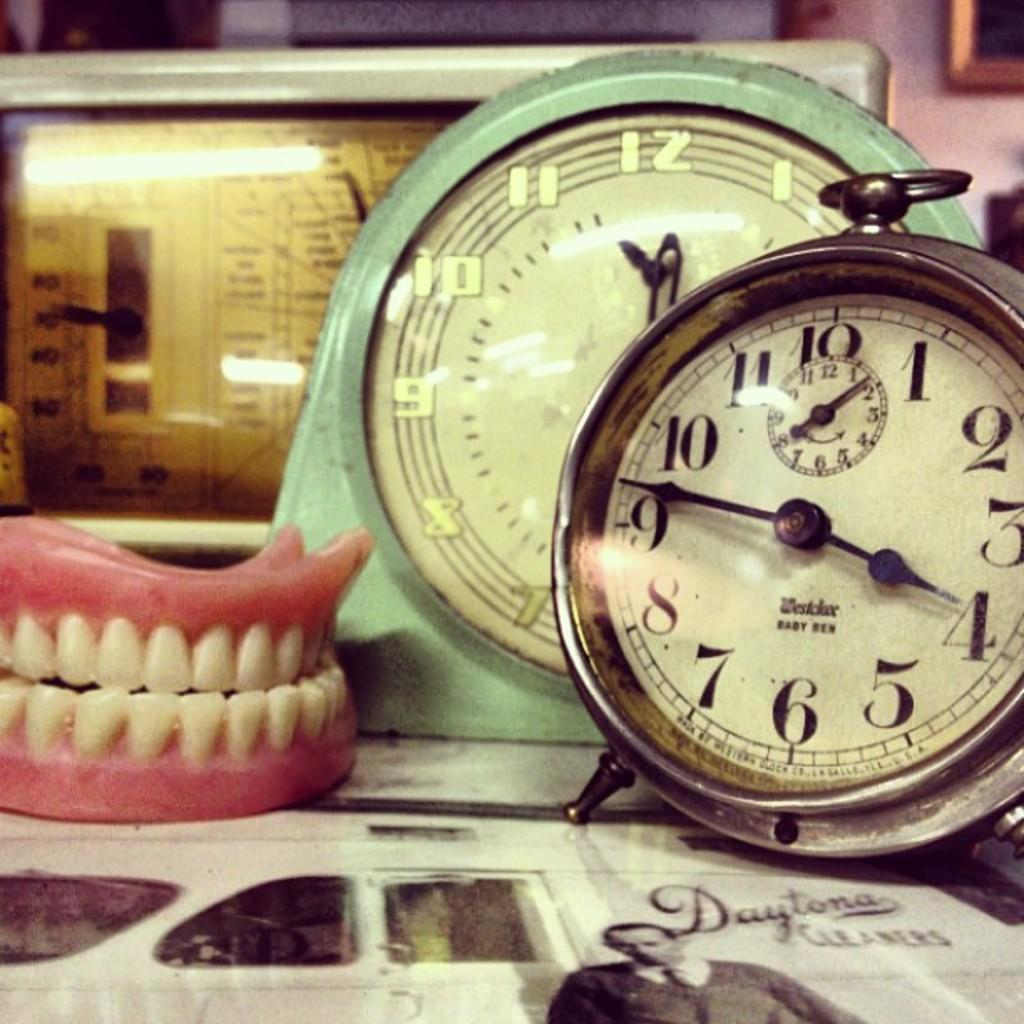<image>
Create a compact narrative representing the image presented. A couple of clocks to the right of a fake set of teeth 